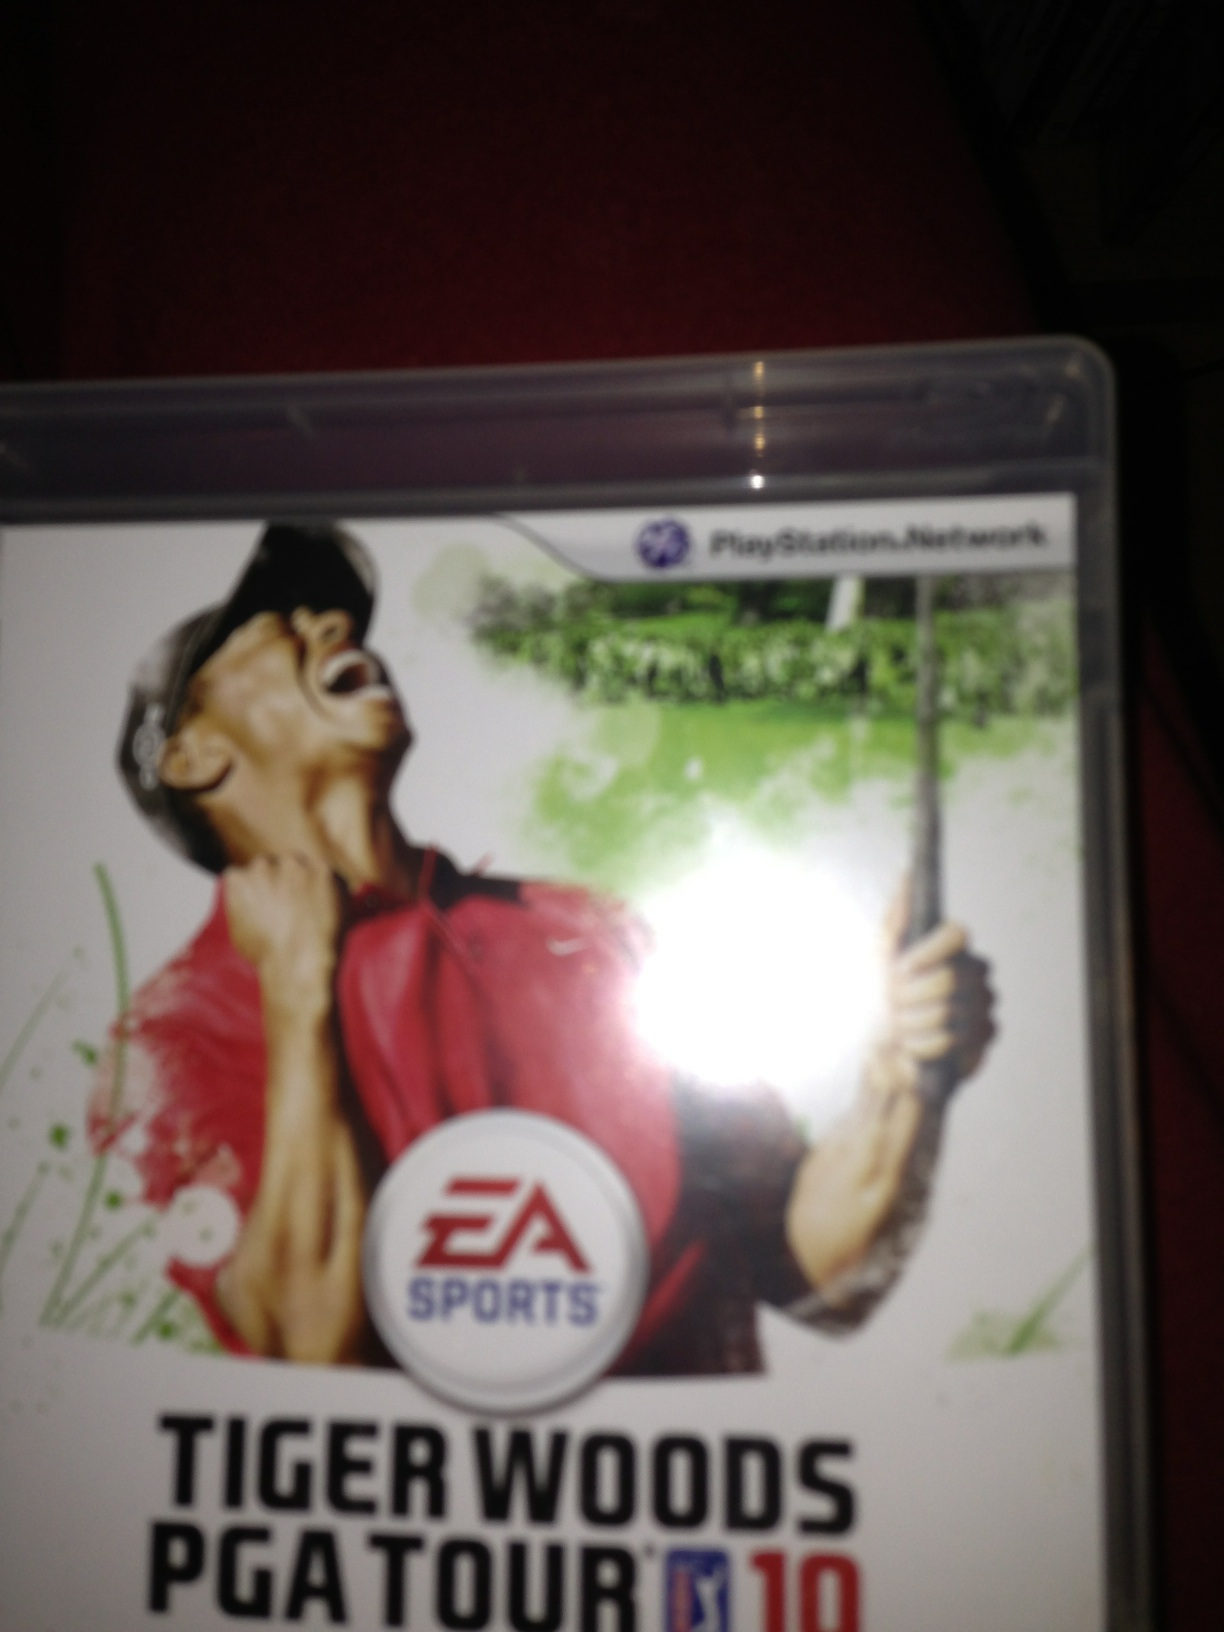Can you describe the gameplay experience of this game? Certainly! 'Tiger Woods PGA Tour 10' offers a highly immersive golf simulation experience. Players can partake in various golfing challenges across realistic, carefully recreated courses. The game includes detailed weather conditions, realistic physics, and numerous modes such as career mode, online multiplayer, and tournaments. It also features the innovative 'Precision Putt' and 'Tournament Challenges' that add to the dynamic gameplay. What are some of the unique features in 'Tiger Woods PGA Tour 10'? Some of the standout features of 'Tiger Woods PGA Tour 10' include the real-time weather integration powered by The Weather Channel, which affects gameplay by altering course conditions. The Wii version introduced the Wii MotionPlus, enhancing swing control for more precise gameplay. Players can also experience the U.S. Open, one of the most iconic tournaments, for the first time in the series. The inclusion of new mini-games and a comprehensive online leaderboard system adds to the game's competitive spirit. What kind of real-life events does the game simulate? The game simulates various real-life golf events and tournaments, most notably the U.S. Open. Players can experience the thrill of participating in this prestigious tournament, complete with authentic course layouts such as Bethpage Black. Additionally, the game recreates other famous golf events, allowing players to compete in both historical and contemporary golfing challenges. Could you imagine a fantastical game mode that could be included in this game? Imagine a mode called 'Mythical Golfing Realms,' where players could golf in fantasy-inspired courses, such as floating islands in the sky, enchanted forests, or ancient ruins inhabited by mythical creatures. Each fantasy course would have its own set of magical challenges, like avoiding dragon fire and navigating through teleportation portals. Power-ups like enchanted golf balls that can fly or curve around obstacles would make gameplay even more exciting and adventurous. 